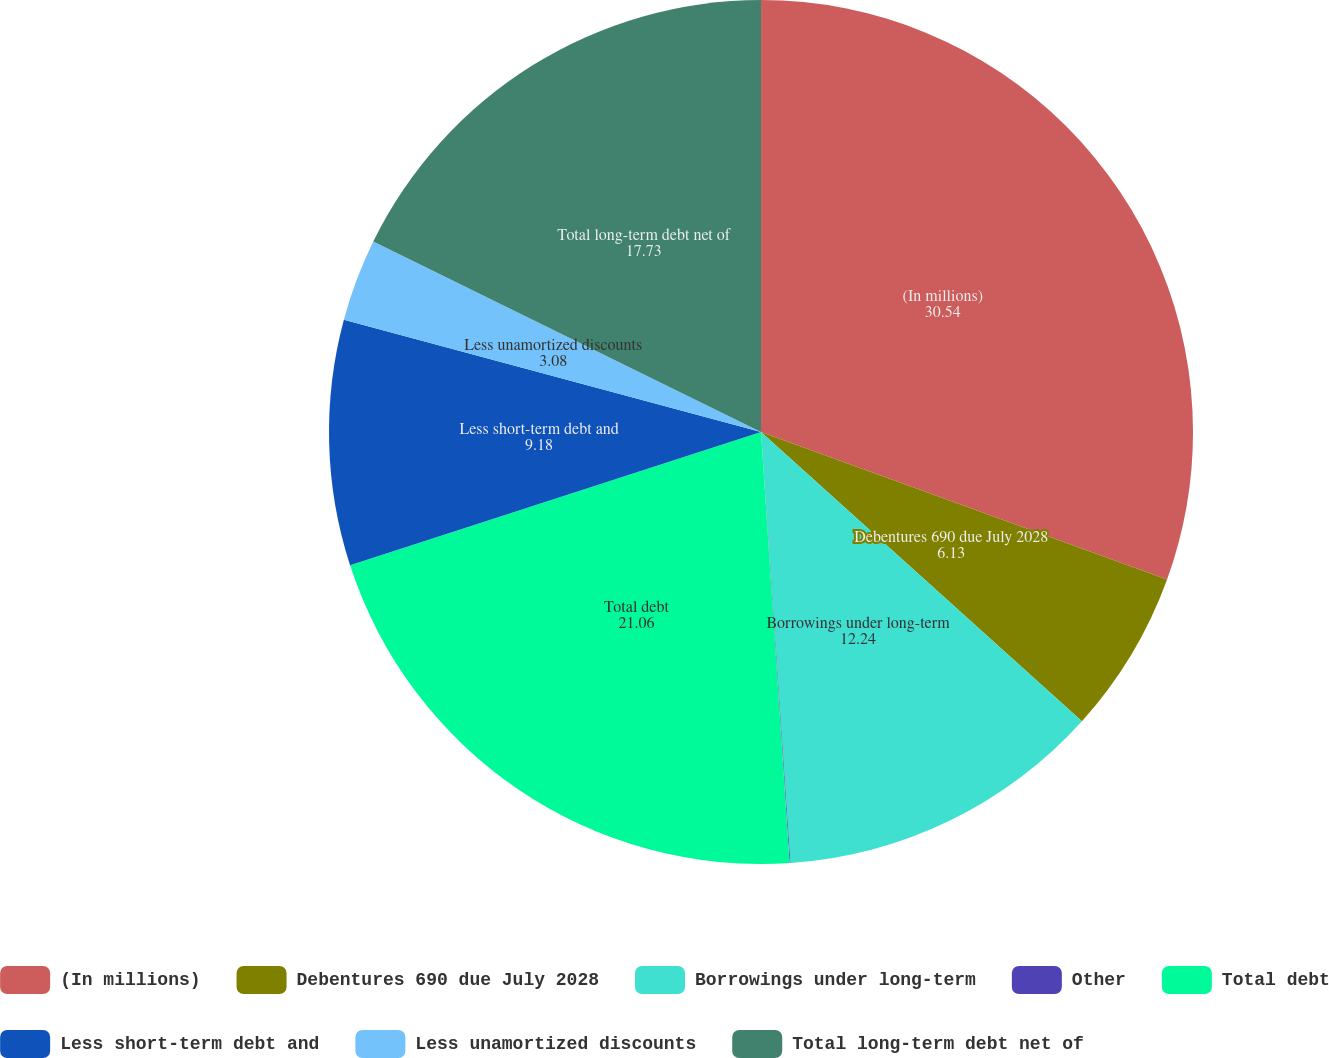<chart> <loc_0><loc_0><loc_500><loc_500><pie_chart><fcel>(In millions)<fcel>Debentures 690 due July 2028<fcel>Borrowings under long-term<fcel>Other<fcel>Total debt<fcel>Less short-term debt and<fcel>Less unamortized discounts<fcel>Total long-term debt net of<nl><fcel>30.54%<fcel>6.13%<fcel>12.24%<fcel>0.03%<fcel>21.06%<fcel>9.18%<fcel>3.08%<fcel>17.73%<nl></chart> 